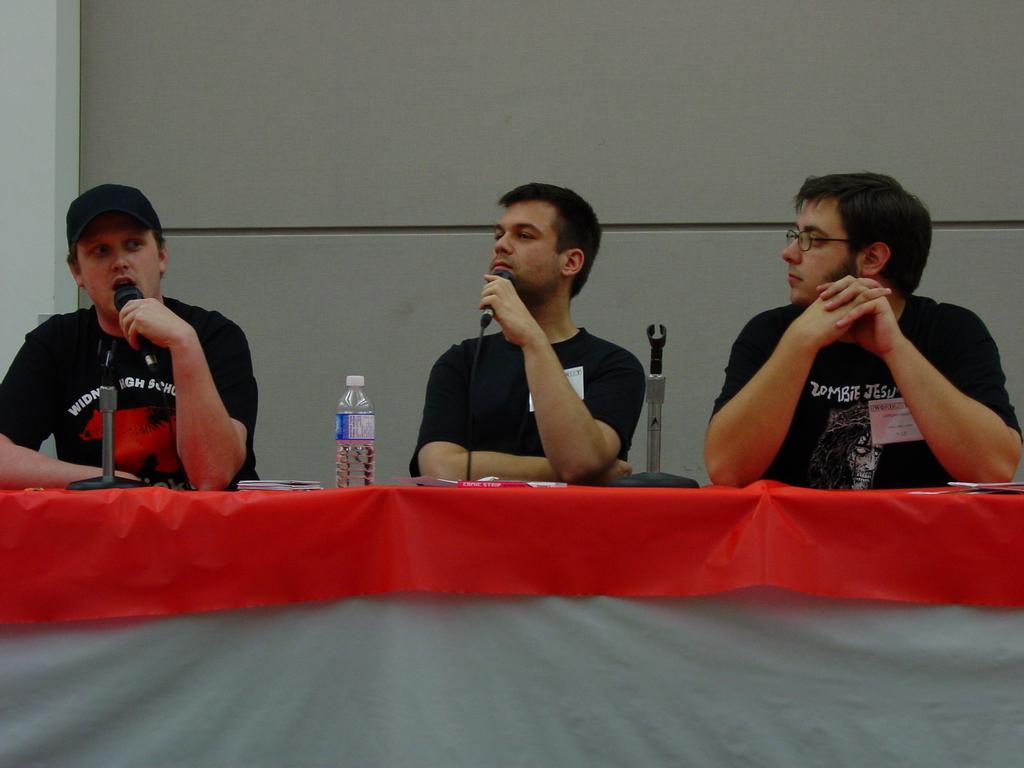In one or two sentences, can you explain what this image depicts? The three people are sitting on a chair. There is a table. There is a bottle ,microphone on a table. 